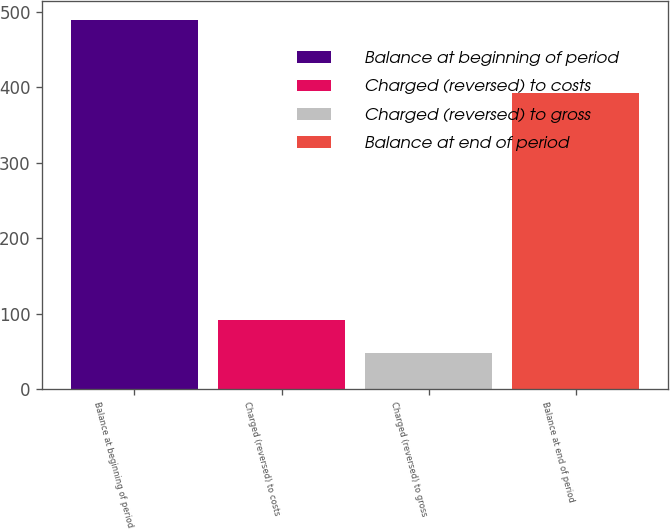Convert chart. <chart><loc_0><loc_0><loc_500><loc_500><bar_chart><fcel>Balance at beginning of period<fcel>Charged (reversed) to costs<fcel>Charged (reversed) to gross<fcel>Balance at end of period<nl><fcel>489.9<fcel>91.74<fcel>47.5<fcel>392.9<nl></chart> 